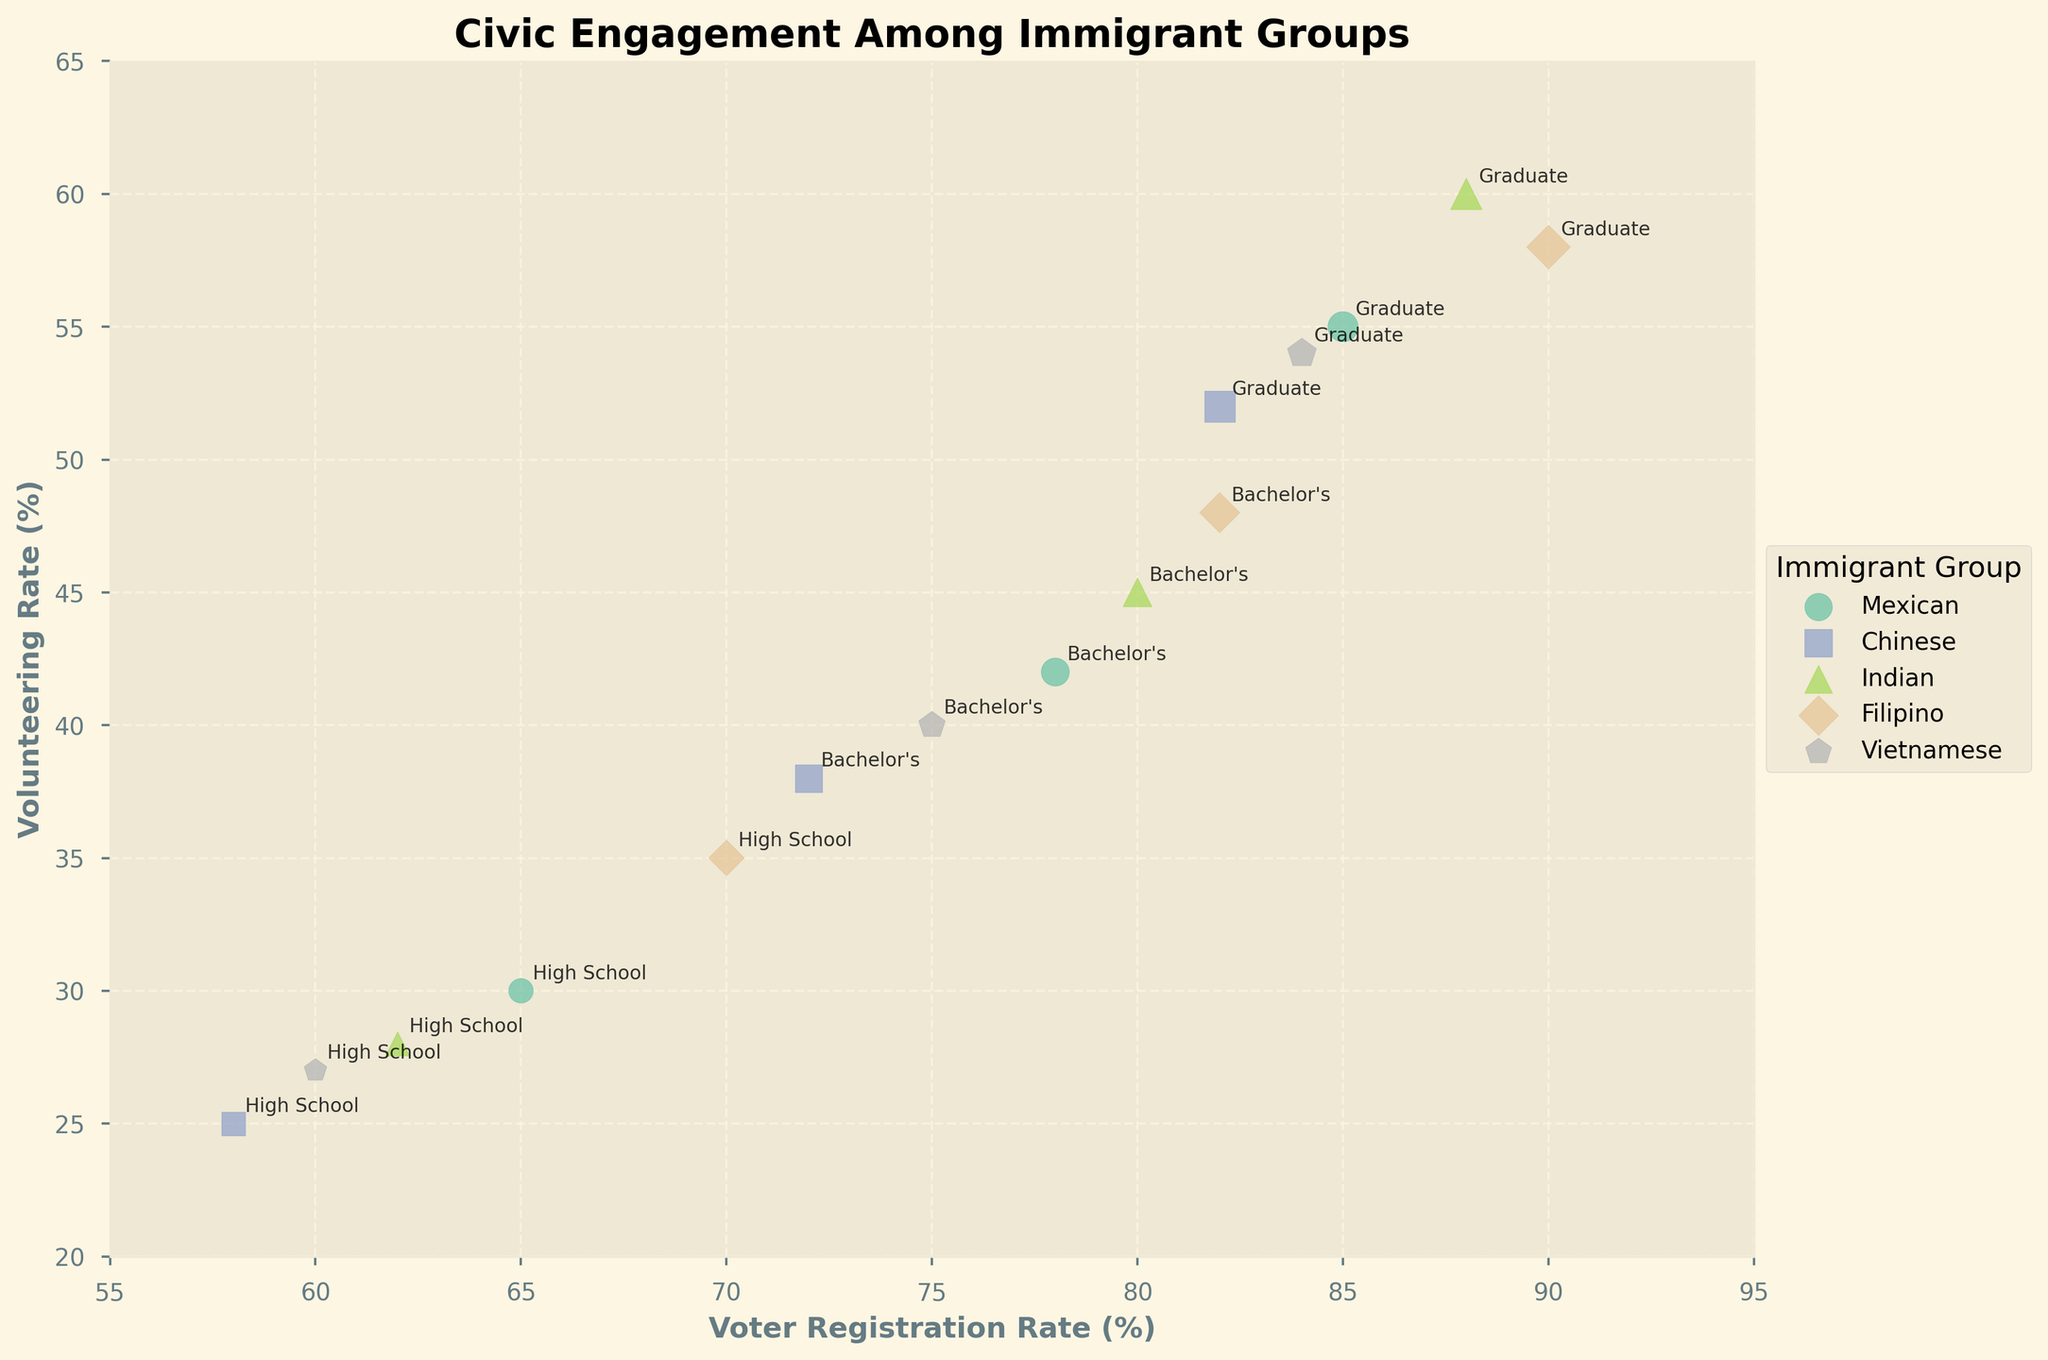What is the title of the figure? Look at the top of the figure to find the title text.
Answer: Civic Engagement Among Immigrant Groups What are the axes labels on the figure? Check the horizontal and vertical axes for their respective labels.
Answer: Voter Registration Rate (%) and Volunteering Rate (%) Which immigrant group has the highest volunteer rate among graduate-level educated individuals? Look for the markers labeled "Graduate" and compare their y-axis positions.
Answer: Indian How many unique immigrant groups are shown in the plot? Count the number of different labels under the legend on the right.
Answer: 5 What is the voter registration rate and volunteering rate for Chinese immigrants with a high school education? Find the "Chinese" data points and locate the marker labeled "High School" to read its position.
Answer: 58% voter registration, 25% volunteering Which immigrant group shows the most significant increase in volunteering rate as education level increases from High School to Graduate? Compare the y-axis positions of High School and Graduate markers within each group, looking for the largest difference.
Answer: Indian Are there any immigrant groups where the voter registration rate for individuals with a bachelor's degree is higher than 80%? Check the markers labeled "Bachelor's" and see if any are above 80% on the x-axis.
Answer: Filipino, Indian What is the average political participation score for Mexican immigrants across all education levels? Find the size of the markers for "Mexican" and compute the average, knowing size is proportional to the participation score. (5.2 + 6.8 + 7.9)/3
Answer: 6.63 Which group has a higher political participation score among bachelor's degree holders, Chinese or Vietnamese immigrants? Compare the size of markers labeled "Bachelor's" for Chinese and Vietnamese groups.
Answer: Chinese How does the voter registration rate for Filipino immigrants with a high school education compare to the same rate for Vietnamese immigrants with a graduate education? Identify the positions of the markers for "Filipino, High School" and "Vietnamese, Graduate" on the x-axis and compare.
Answer: Filipino, High School: 70%, Vietnamese, Graduate: 84% 